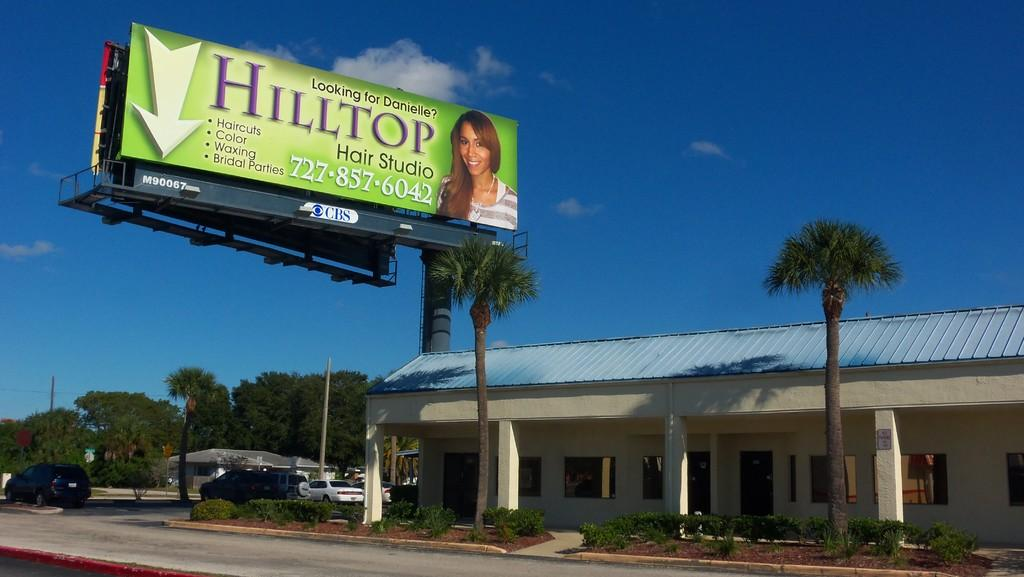Provide a one-sentence caption for the provided image. a building with a billboard saying Hilltop on it. 